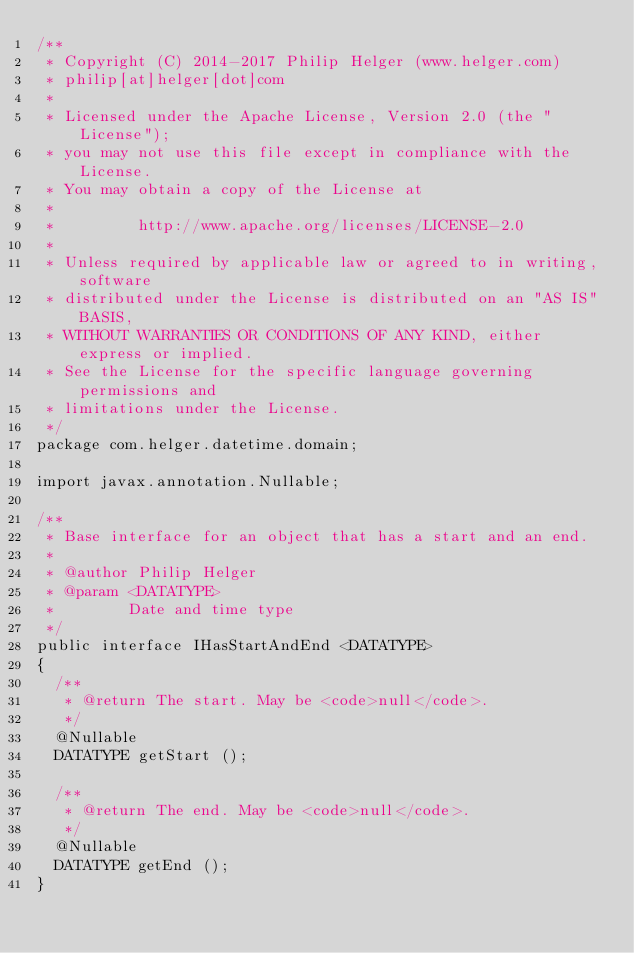Convert code to text. <code><loc_0><loc_0><loc_500><loc_500><_Java_>/**
 * Copyright (C) 2014-2017 Philip Helger (www.helger.com)
 * philip[at]helger[dot]com
 *
 * Licensed under the Apache License, Version 2.0 (the "License");
 * you may not use this file except in compliance with the License.
 * You may obtain a copy of the License at
 *
 *         http://www.apache.org/licenses/LICENSE-2.0
 *
 * Unless required by applicable law or agreed to in writing, software
 * distributed under the License is distributed on an "AS IS" BASIS,
 * WITHOUT WARRANTIES OR CONDITIONS OF ANY KIND, either express or implied.
 * See the License for the specific language governing permissions and
 * limitations under the License.
 */
package com.helger.datetime.domain;

import javax.annotation.Nullable;

/**
 * Base interface for an object that has a start and an end.
 *
 * @author Philip Helger
 * @param <DATATYPE>
 *        Date and time type
 */
public interface IHasStartAndEnd <DATATYPE>
{
  /**
   * @return The start. May be <code>null</code>.
   */
  @Nullable
  DATATYPE getStart ();

  /**
   * @return The end. May be <code>null</code>.
   */
  @Nullable
  DATATYPE getEnd ();
}
</code> 